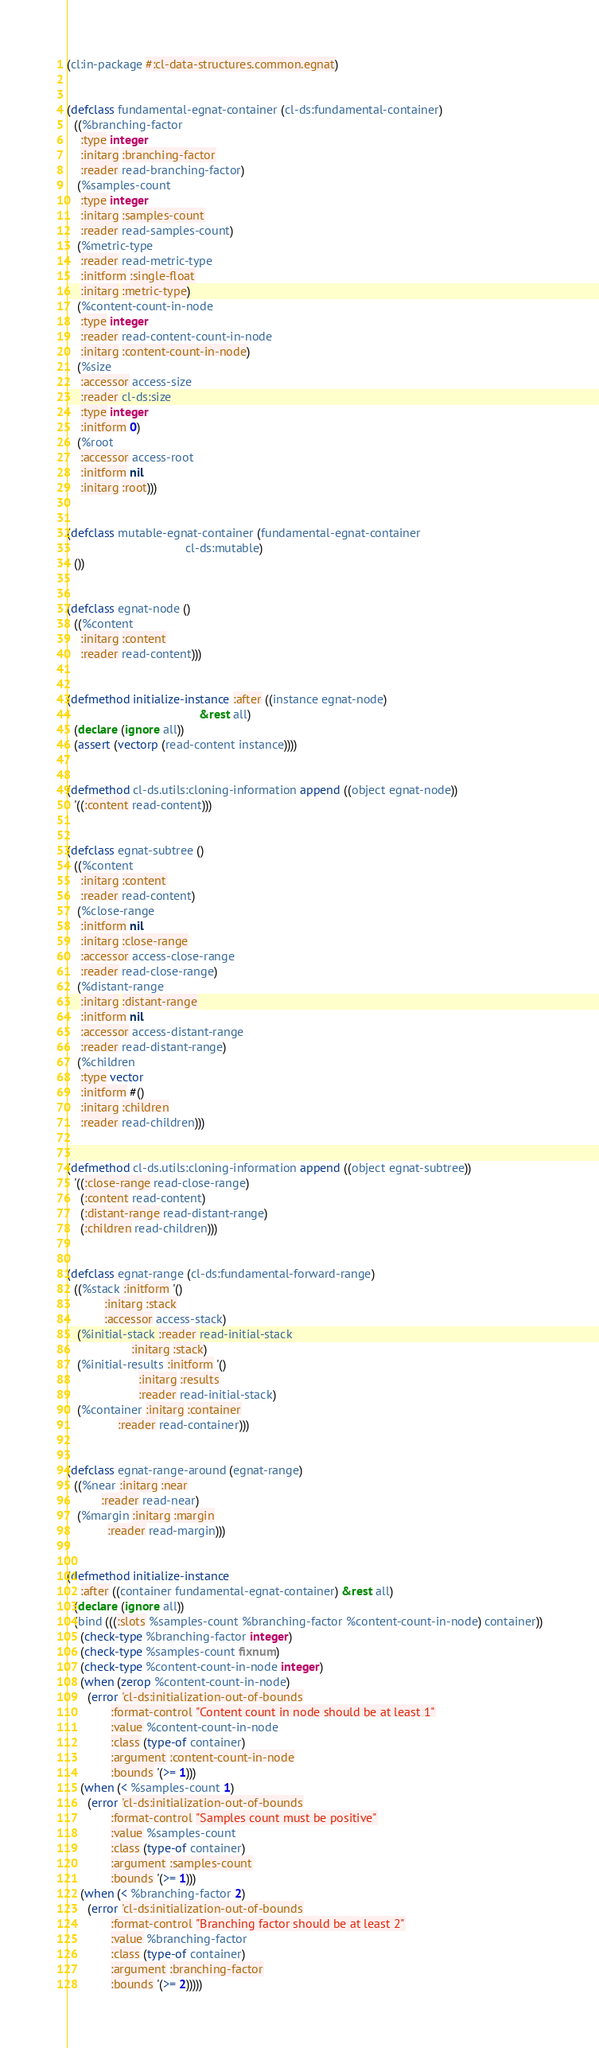Convert code to text. <code><loc_0><loc_0><loc_500><loc_500><_Lisp_>(cl:in-package #:cl-data-structures.common.egnat)


(defclass fundamental-egnat-container (cl-ds:fundamental-container)
  ((%branching-factor
    :type integer
    :initarg :branching-factor
    :reader read-branching-factor)
   (%samples-count
    :type integer
    :initarg :samples-count
    :reader read-samples-count)
   (%metric-type
    :reader read-metric-type
    :initform :single-float
    :initarg :metric-type)
   (%content-count-in-node
    :type integer
    :reader read-content-count-in-node
    :initarg :content-count-in-node)
   (%size
    :accessor access-size
    :reader cl-ds:size
    :type integer
    :initform 0)
   (%root
    :accessor access-root
    :initform nil
    :initarg :root)))


(defclass mutable-egnat-container (fundamental-egnat-container
                                   cl-ds:mutable)
  ())


(defclass egnat-node ()
  ((%content
    :initarg :content
    :reader read-content)))


(defmethod initialize-instance :after ((instance egnat-node)
                                       &rest all)
  (declare (ignore all))
  (assert (vectorp (read-content instance))))


(defmethod cl-ds.utils:cloning-information append ((object egnat-node))
  '((:content read-content)))


(defclass egnat-subtree ()
  ((%content
    :initarg :content
    :reader read-content)
   (%close-range
    :initform nil
    :initarg :close-range
    :accessor access-close-range
    :reader read-close-range)
   (%distant-range
    :initarg :distant-range
    :initform nil
    :accessor access-distant-range
    :reader read-distant-range)
   (%children
    :type vector
    :initform #()
    :initarg :children
    :reader read-children)))


(defmethod cl-ds.utils:cloning-information append ((object egnat-subtree))
  '((:close-range read-close-range)
    (:content read-content)
    (:distant-range read-distant-range)
    (:children read-children)))


(defclass egnat-range (cl-ds:fundamental-forward-range)
  ((%stack :initform '()
           :initarg :stack
           :accessor access-stack)
   (%initial-stack :reader read-initial-stack
                   :initarg :stack)
   (%initial-results :initform '()
                     :initarg :results
                     :reader read-initial-stack)
   (%container :initarg :container
               :reader read-container)))


(defclass egnat-range-around (egnat-range)
  ((%near :initarg :near
          :reader read-near)
   (%margin :initarg :margin
            :reader read-margin)))


(defmethod initialize-instance
    :after ((container fundamental-egnat-container) &rest all)
  (declare (ignore all))
  (bind (((:slots %samples-count %branching-factor %content-count-in-node) container))
    (check-type %branching-factor integer)
    (check-type %samples-count fixnum)
    (check-type %content-count-in-node integer)
    (when (zerop %content-count-in-node)
      (error 'cl-ds:initialization-out-of-bounds
             :format-control "Content count in node should be at least 1"
             :value %content-count-in-node
             :class (type-of container)
             :argument :content-count-in-node
             :bounds '(>= 1)))
    (when (< %samples-count 1)
      (error 'cl-ds:initialization-out-of-bounds
             :format-control "Samples count must be positive"
             :value %samples-count
             :class (type-of container)
             :argument :samples-count
             :bounds '(>= 1)))
    (when (< %branching-factor 2)
      (error 'cl-ds:initialization-out-of-bounds
             :format-control "Branching factor should be at least 2"
             :value %branching-factor
             :class (type-of container)
             :argument :branching-factor
             :bounds '(>= 2)))))
</code> 